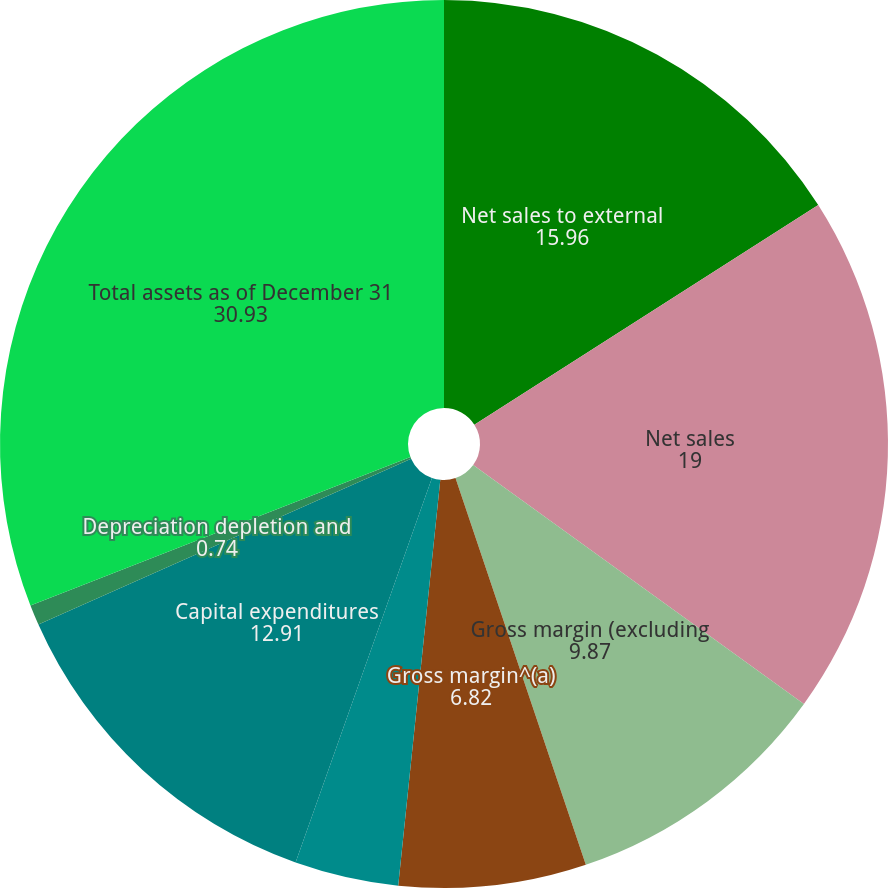Convert chart. <chart><loc_0><loc_0><loc_500><loc_500><pie_chart><fcel>Net sales to external<fcel>Net sales<fcel>Gross margin (excluding<fcel>Gross margin^(a)<fcel>Operating earnings (loss)<fcel>Capital expenditures<fcel>Depreciation depletion and<fcel>Total assets as of December 31<nl><fcel>15.96%<fcel>19.0%<fcel>9.87%<fcel>6.82%<fcel>3.78%<fcel>12.91%<fcel>0.74%<fcel>30.93%<nl></chart> 